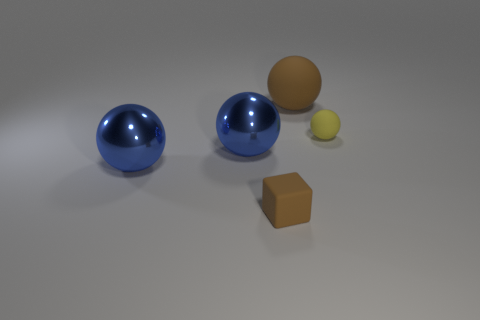Subtract all purple cubes. How many blue balls are left? 2 Add 4 green cylinders. How many objects exist? 9 Subtract all large balls. How many balls are left? 1 Subtract 1 spheres. How many spheres are left? 3 Subtract all yellow spheres. How many spheres are left? 3 Subtract all cubes. How many objects are left? 4 Subtract all brown balls. Subtract all green cylinders. How many balls are left? 3 Add 4 small yellow matte cylinders. How many small yellow matte cylinders exist? 4 Subtract 0 blue cubes. How many objects are left? 5 Subtract all big rubber objects. Subtract all yellow objects. How many objects are left? 3 